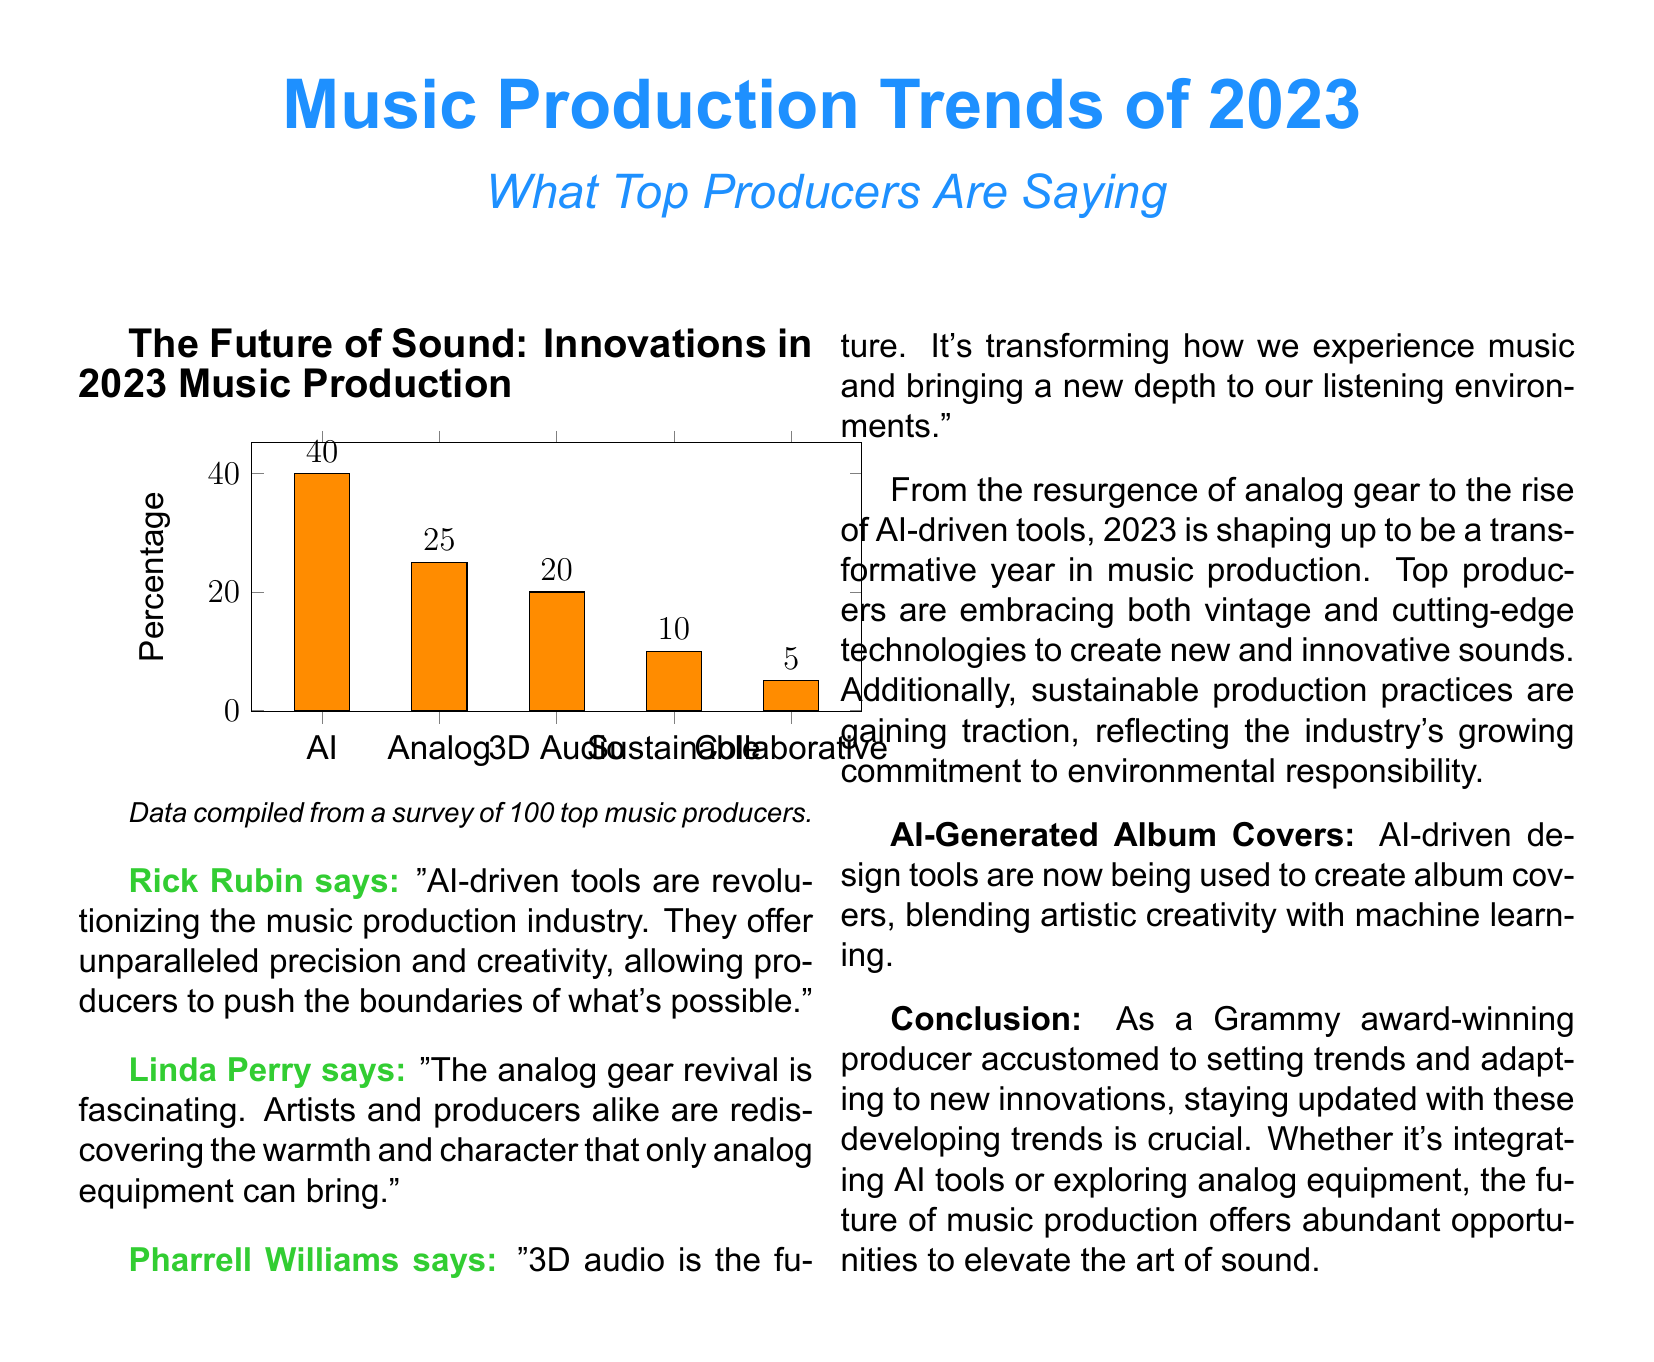What percentage of producers favor AI in music production? AI is favored by 40% of producers according to the survey data presented in the document.
Answer: 40% Who commented on the analog gear revival? Linda Perry is the one who commented on the analog gear revival in the document.
Answer: Linda Perry What is the percentage of producers who prefer collaborative production? The document states that 5% of producers prefer collaborative production.
Answer: 5% Which technology is said to transform listening environments? Pharrell Williams mentioned that 3D audio is transforming listening environments.
Answer: 3D audio What percentage of producers support sustainable production practices? Sustainable production practices are supported by 10% of producers according to the data in the document.
Answer: 10% How many top music producers were surveyed? The document indicates that 100 top music producers were surveyed for the data.
Answer: 100 What is the main theme of the document? The main theme revolves around music production trends and insights from top producers in 2023.
Answer: Music production trends What color represents the chart in the document? The chart color used in the document is orange, referred to as chartcolor.
Answer: Orange 